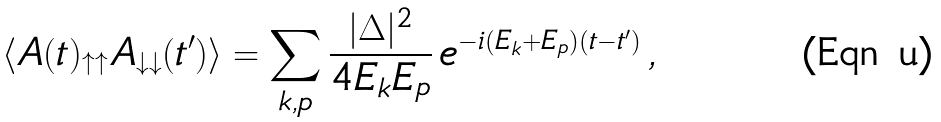<formula> <loc_0><loc_0><loc_500><loc_500>\langle A ( t ) _ { \uparrow \uparrow } A _ { \downarrow \downarrow } ( t ^ { \prime } ) \rangle = \sum _ { k , p } \frac { | \Delta | ^ { 2 } } { 4 E _ { k } E _ { p } } \, e ^ { - i ( E _ { k } + E _ { p } ) ( t - t ^ { \prime } ) } \, ,</formula> 